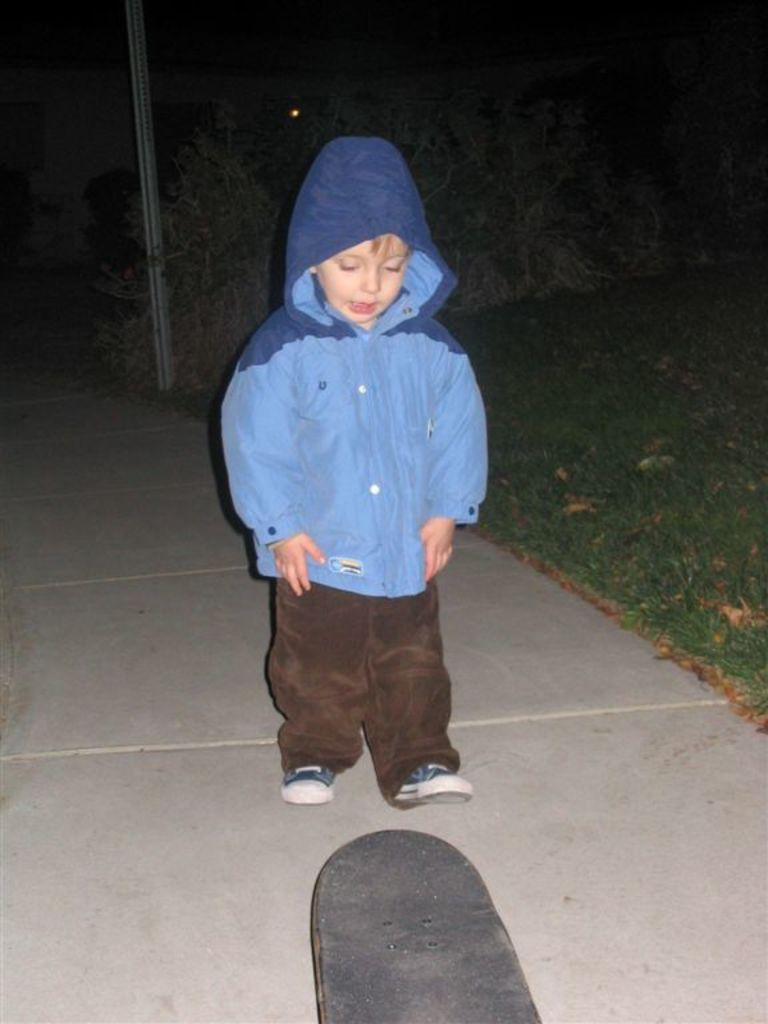What is the main subject of the image? There is a small boy in the center of the image. What can be seen in the background of the image? There is greenery in the background of the image. How many matches are visible in the image? There are no matches present in the image. What type of flowers can be seen in the image? There is no mention of flowers in the image; it only features a small boy and greenery in the background. 